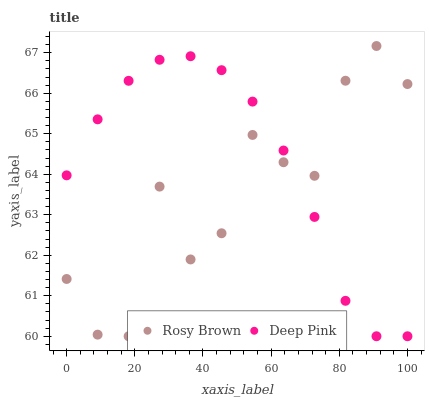Does Rosy Brown have the minimum area under the curve?
Answer yes or no. Yes. Does Deep Pink have the maximum area under the curve?
Answer yes or no. Yes. Does Deep Pink have the minimum area under the curve?
Answer yes or no. No. Is Deep Pink the smoothest?
Answer yes or no. Yes. Is Rosy Brown the roughest?
Answer yes or no. Yes. Is Deep Pink the roughest?
Answer yes or no. No. Does Rosy Brown have the lowest value?
Answer yes or no. Yes. Does Rosy Brown have the highest value?
Answer yes or no. Yes. Does Deep Pink have the highest value?
Answer yes or no. No. Does Deep Pink intersect Rosy Brown?
Answer yes or no. Yes. Is Deep Pink less than Rosy Brown?
Answer yes or no. No. Is Deep Pink greater than Rosy Brown?
Answer yes or no. No. 